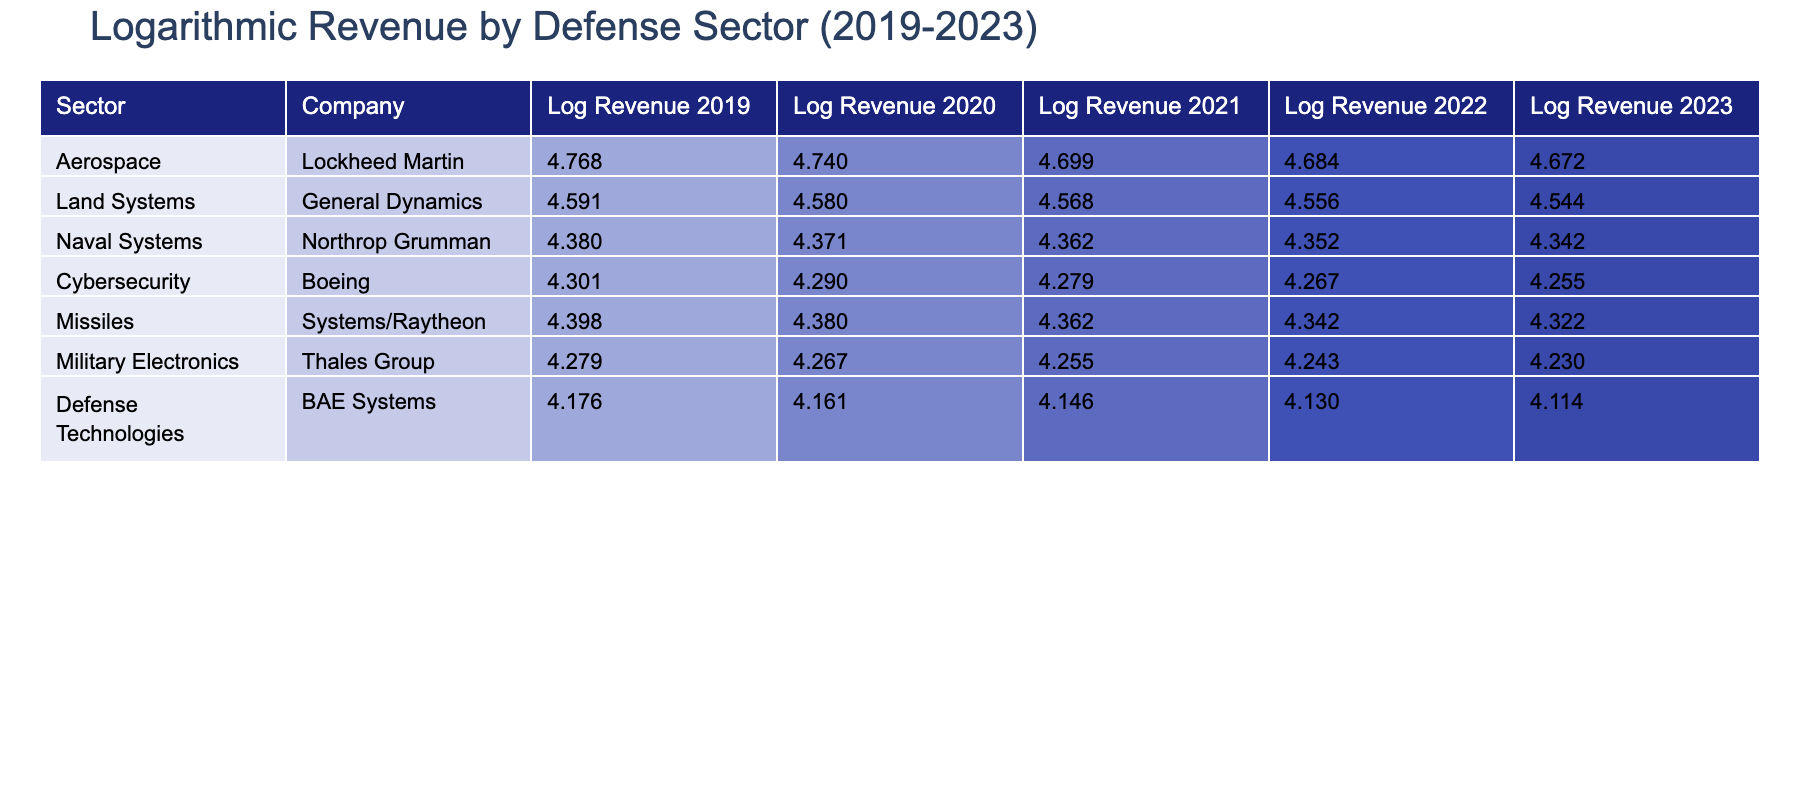What was the highest logarithmic revenue recorded in the Aerospace sector in 2023? The table reveals that Lockheed Martin, within the Aerospace sector, recorded a revenue of 58600 million in 2023. Logarithmically transformed, this revenue becomes log10(58600) ≈ 4.768. No other sector has a higher value than this one.
Answer: 4.768 Which company in Land Systems generated the least revenue in 2021? From the table, General Dynamics is the only company listed under the Land Systems sector, with a revenue of 37000 million in 2021. Since it is the only entity present, it is thus the least revenue-generating company in that sector for that year.
Answer: 37000 What is the overall trend in logarithmic revenue for Cybersecurity from 2019 to 2023? By examining the logarithmic values in the Cybersecurity row, the revenues have increased from log10(18000) ≈ 4.255 in 2019 to log10(20000) ≈ 4.301 in 2023. This indicates a consistent upward trend over the five-year period.
Answer: Increased Is the revenue generated by Missiles Systems in 2022 higher than that of Cybersecurity in 2021? Looking into the table, the revenue for Missiles Systems in 2022 is 24000 million, resulting in log10(24000) ≈ 4.380. For Cybersecurity in 2021, the revenue is 19000 million, giving log10(19000) ≈ 4.278. Since 4.380 is greater than 4.278, it confirms that the revenue in 2022 for Missiles Systems is higher.
Answer: Yes What are the differences in logarithmic revenue for Naval Systems between 2020 and 2023? For Naval Systems, the revenue in 2023 is 24000 million, converting to log10(24000) ≈ 4.380. In 2020, the revenue was 22500 million, which converts to log10(22500) ≈ 4.352. The difference between these two values is 4.380 - 4.352 = 0.028, indicating a positive change over the three years.
Answer: 0.028 Was there any sector that had a consistent logarithmic revenue increase from 2019 to 2023? By reviewing the logarithmic revenues for each sector, it is apparent that all sectors saw increases in revenue over the five-year period. For example, Aerospace started at log10(47000) in 2019 and reached log10(58600) in 2023, showing consistency in growth across all sectors.
Answer: Yes What is the average logarithmic revenue of Military Electronics over the five years? First, calculate the logarithmic revenues for Military Electronics from 2019 to 2023: log10(17000) ≈ 4.230, log10(17500) ≈ 4.243, log10(18000) ≈ 4.255, log10(18500) ≈ 4.267, and log10(19000) ≈ 4.278. Now, sum these values: 4.230 + 4.243 + 4.255 + 4.267 + 4.278 = 21.273, and divide by 5 for the average: 21.273 / 5 ≈ 4.255.
Answer: 4.255 What sector had the highest logarithmic revenue in 2021? From the table, we look at the revenues for each sector in 2021. The Aerospace sector generated 50000 million, translating to log10(50000) ≈ 4.699, which is the highest value compared to the others in 2021.
Answer: Aerospace 